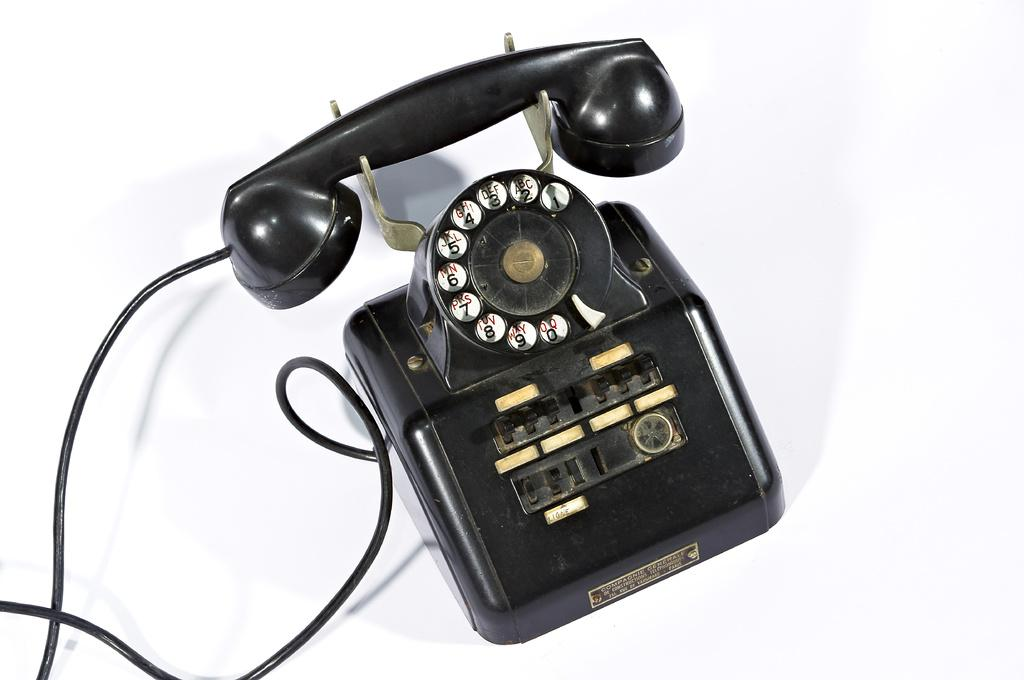What type of telephone is in the image? There is a black telephone in the image. What is connected to the telephone in the image? There is a cable in the image. On what object is the cable resting? The cable is on a white object. How does the telephone help with dusting in the image? The telephone does not help with dusting in the image; it is a communication device and not related to cleaning. 